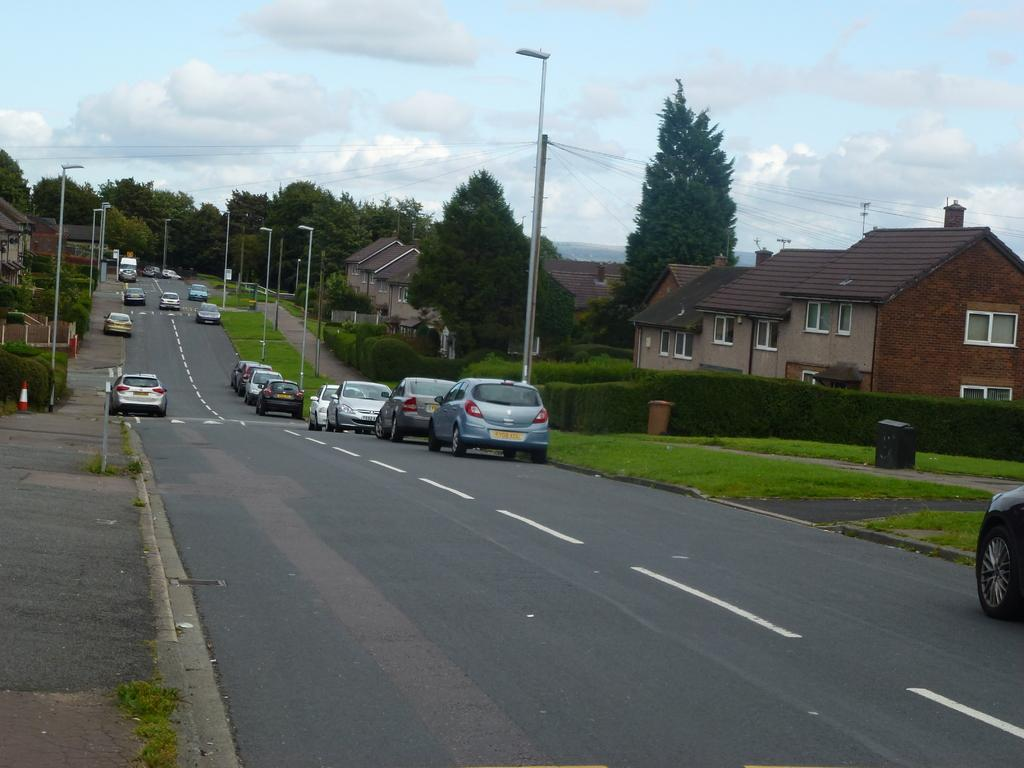What can be seen on the road in the image? There are vehicles on the road in the image. What type of vegetation is visible in the image? There is grass visible in the image. What structures are present in the image? Light poles and buildings with windows are present in the image. What else can be seen in the image besides the vehicles and structures? Trees are visible in the image. What is visible in the background of the image? The sky with clouds is visible in the background of the image. What type of meat is hanging on the wall in the image? There is no meat or wall present in the image. What kind of stage can be seen in the image? There is no stage present in the image. 